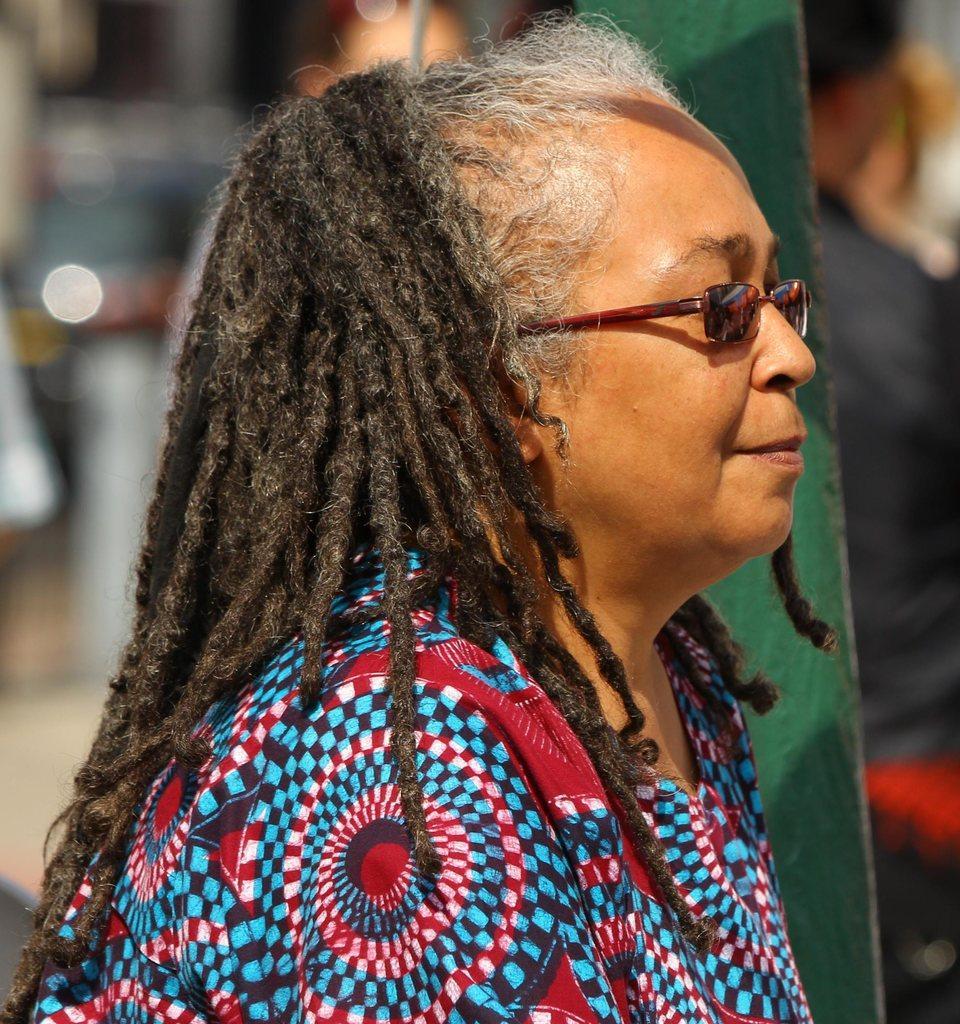Please provide a concise description of this image. In the center of the image we can see a lady is wearing spectacles, dress. On the right side of the image we can see a pole. In the background, the image is blur. 